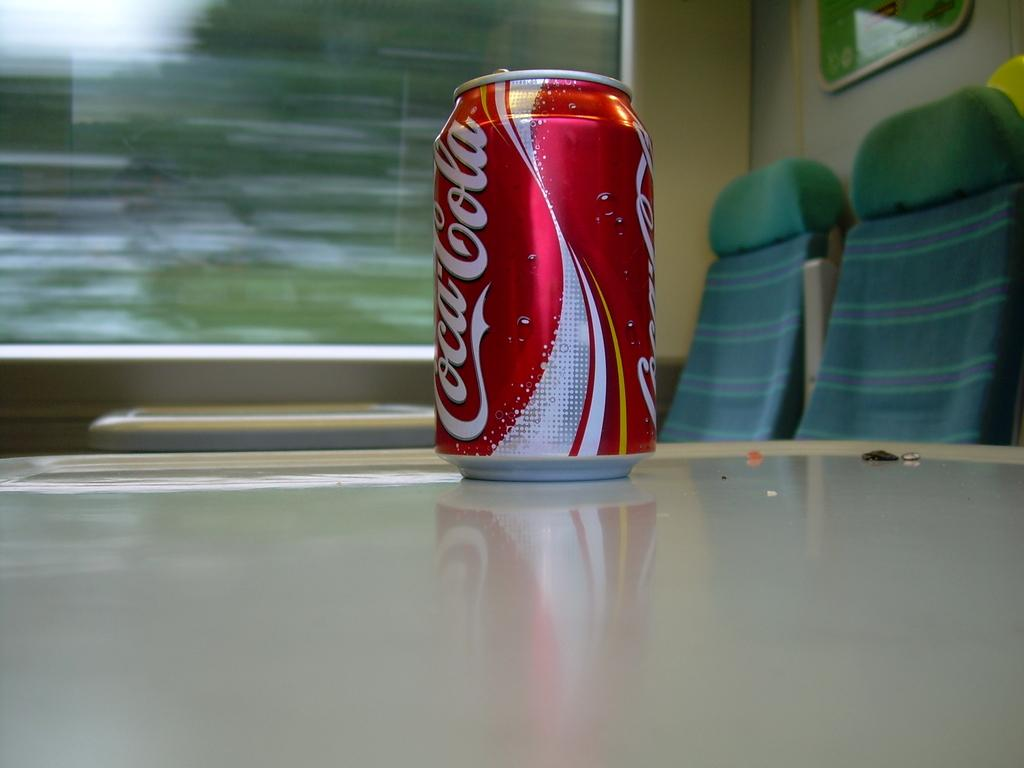What is the color of the tin on the table in the image? The tin on the table is red and white in color. What is the color of the seats in the image? The seats in the image are green in color. What is attached to the wall in the image? There is a broad attached to the wall in the image. What is visible through the window in the image? The presence of a glass window suggests that there is a view of the outside, but the specifics cannot be determined from the provided facts. What type of chalk is being used to write on the broad in the image? There is no chalk present in the image, and therefore no such activity can be observed. How does the division between the two green seats appear in the image? The image does not show any division between the two green seats; they are simply positioned next to each other. 